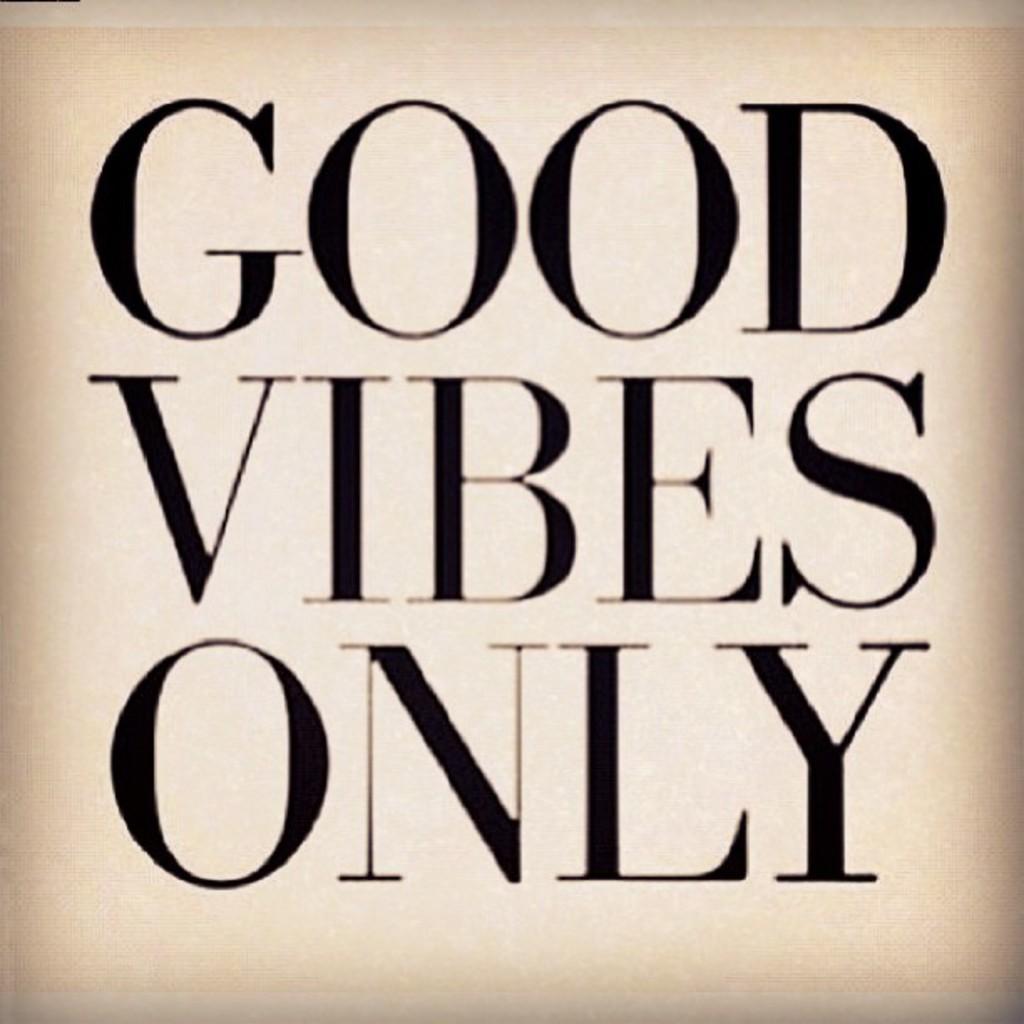Could you give a brief overview of what you see in this image? This is a zoomed in picture. In the center we can see the text on an object. 